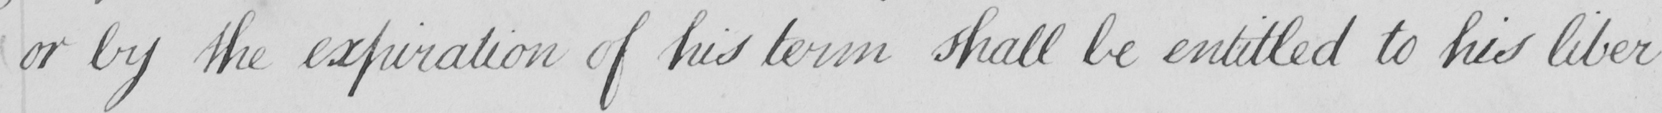Please provide the text content of this handwritten line. or by the expiration of his term shall be entitled to his liber- 